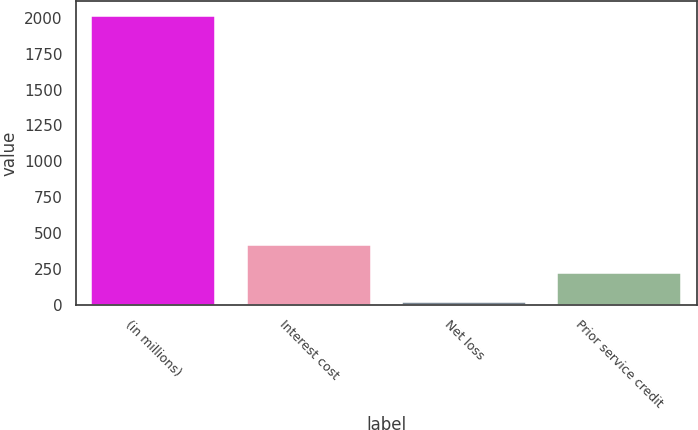<chart> <loc_0><loc_0><loc_500><loc_500><bar_chart><fcel>(in millions)<fcel>Interest cost<fcel>Net loss<fcel>Prior service credit<nl><fcel>2014<fcel>420.4<fcel>22<fcel>221.2<nl></chart> 